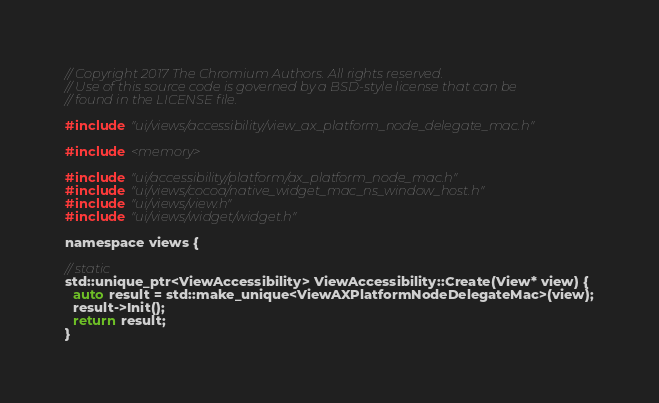Convert code to text. <code><loc_0><loc_0><loc_500><loc_500><_ObjectiveC_>// Copyright 2017 The Chromium Authors. All rights reserved.
// Use of this source code is governed by a BSD-style license that can be
// found in the LICENSE file.

#include "ui/views/accessibility/view_ax_platform_node_delegate_mac.h"

#include <memory>

#include "ui/accessibility/platform/ax_platform_node_mac.h"
#include "ui/views/cocoa/native_widget_mac_ns_window_host.h"
#include "ui/views/view.h"
#include "ui/views/widget/widget.h"

namespace views {

// static
std::unique_ptr<ViewAccessibility> ViewAccessibility::Create(View* view) {
  auto result = std::make_unique<ViewAXPlatformNodeDelegateMac>(view);
  result->Init();
  return result;
}
</code> 